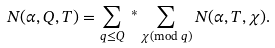Convert formula to latex. <formula><loc_0><loc_0><loc_500><loc_500>N ( \alpha , Q , T ) & = \sum _ { q \leq Q } \ { ^ { * } } \sum _ { \substack { \chi ( \text {mod } q ) } } N ( \alpha , T , \chi ) .</formula> 